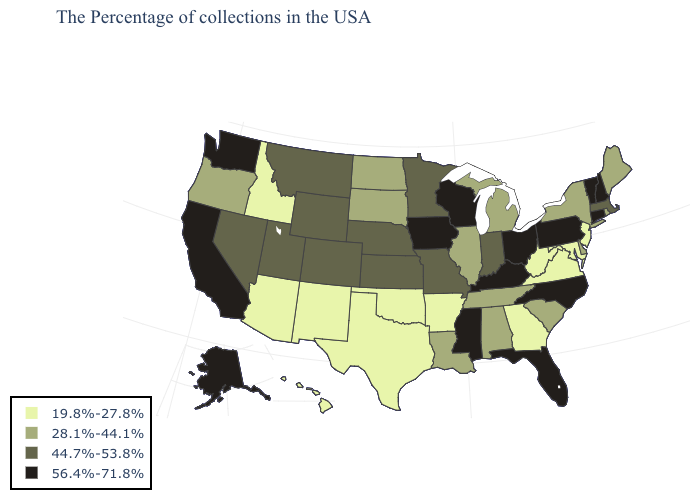Which states have the lowest value in the MidWest?
Short answer required. Michigan, Illinois, South Dakota, North Dakota. Name the states that have a value in the range 19.8%-27.8%?
Give a very brief answer. New Jersey, Maryland, Virginia, West Virginia, Georgia, Arkansas, Oklahoma, Texas, New Mexico, Arizona, Idaho, Hawaii. Does Kentucky have the same value as Iowa?
Quick response, please. Yes. What is the lowest value in states that border Wyoming?
Be succinct. 19.8%-27.8%. Name the states that have a value in the range 28.1%-44.1%?
Be succinct. Maine, Rhode Island, New York, Delaware, South Carolina, Michigan, Alabama, Tennessee, Illinois, Louisiana, South Dakota, North Dakota, Oregon. Among the states that border North Carolina , does Virginia have the lowest value?
Quick response, please. Yes. Which states have the lowest value in the South?
Concise answer only. Maryland, Virginia, West Virginia, Georgia, Arkansas, Oklahoma, Texas. Name the states that have a value in the range 28.1%-44.1%?
Answer briefly. Maine, Rhode Island, New York, Delaware, South Carolina, Michigan, Alabama, Tennessee, Illinois, Louisiana, South Dakota, North Dakota, Oregon. Does Kentucky have the same value as Iowa?
Keep it brief. Yes. Name the states that have a value in the range 56.4%-71.8%?
Keep it brief. New Hampshire, Vermont, Connecticut, Pennsylvania, North Carolina, Ohio, Florida, Kentucky, Wisconsin, Mississippi, Iowa, California, Washington, Alaska. What is the value of Hawaii?
Keep it brief. 19.8%-27.8%. What is the lowest value in the USA?
Quick response, please. 19.8%-27.8%. What is the value of Kentucky?
Give a very brief answer. 56.4%-71.8%. What is the lowest value in states that border Idaho?
Write a very short answer. 28.1%-44.1%. 